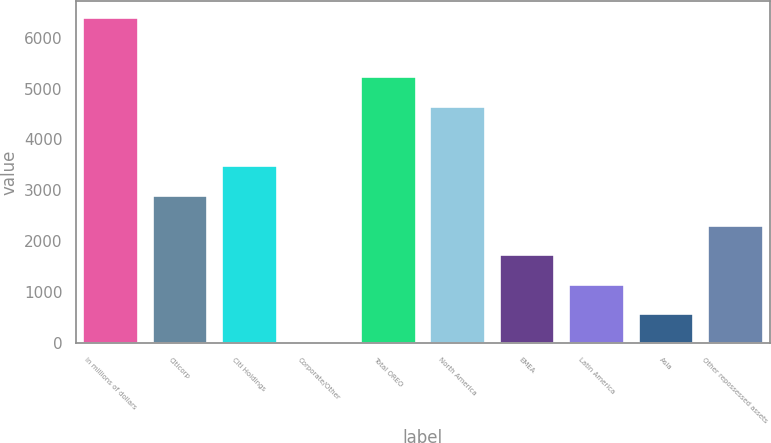Convert chart to OTSL. <chart><loc_0><loc_0><loc_500><loc_500><bar_chart><fcel>In millions of dollars<fcel>Citicorp<fcel>Citi Holdings<fcel>Corporate/Other<fcel>Total OREO<fcel>North America<fcel>EMEA<fcel>Latin America<fcel>Asia<fcel>Other repossessed assets<nl><fcel>6405.2<fcel>2912<fcel>3494.2<fcel>1<fcel>5240.8<fcel>4658.6<fcel>1747.6<fcel>1165.4<fcel>583.2<fcel>2329.8<nl></chart> 